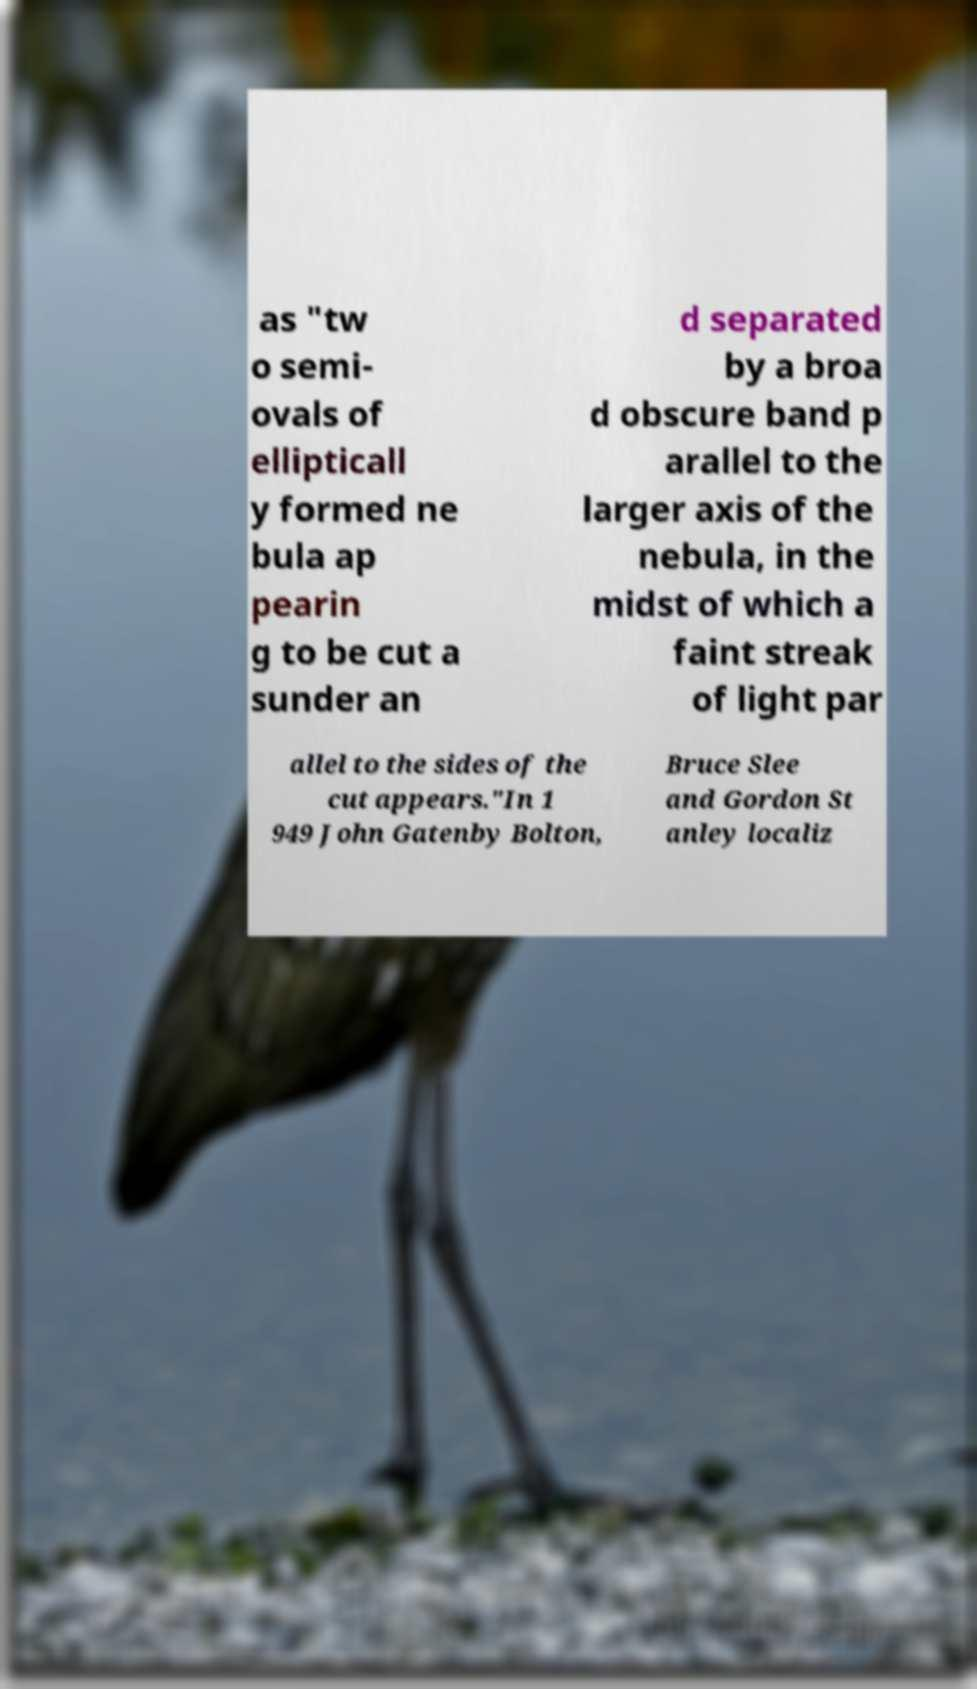Could you assist in decoding the text presented in this image and type it out clearly? as "tw o semi- ovals of ellipticall y formed ne bula ap pearin g to be cut a sunder an d separated by a broa d obscure band p arallel to the larger axis of the nebula, in the midst of which a faint streak of light par allel to the sides of the cut appears."In 1 949 John Gatenby Bolton, Bruce Slee and Gordon St anley localiz 